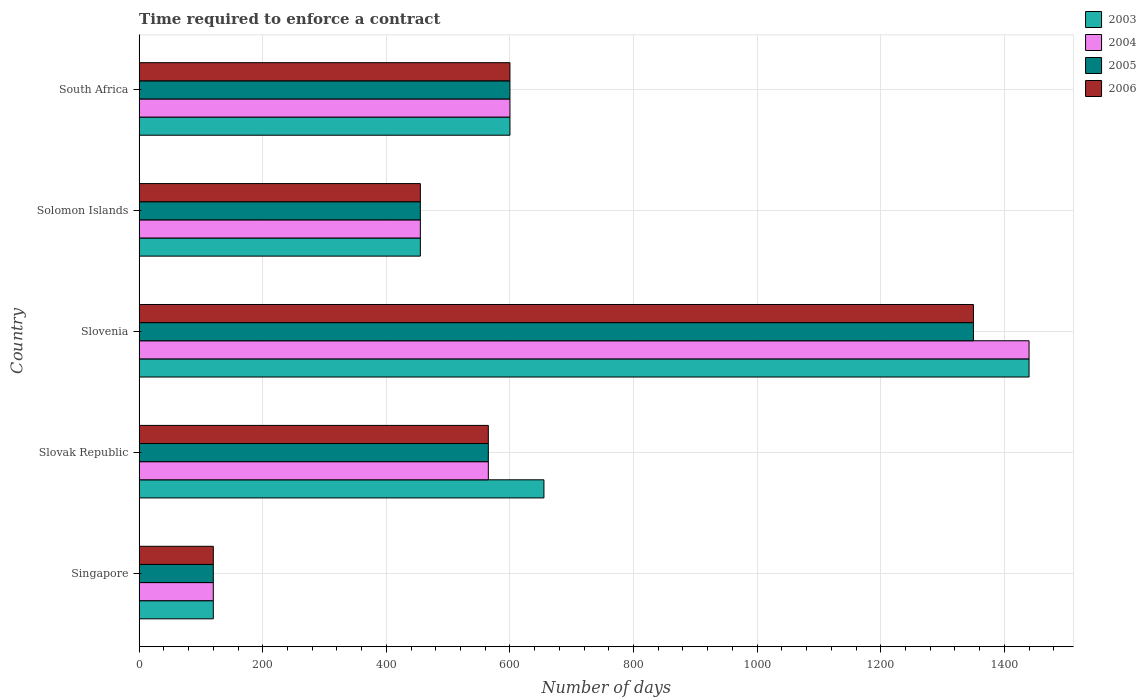Are the number of bars per tick equal to the number of legend labels?
Keep it short and to the point. Yes. Are the number of bars on each tick of the Y-axis equal?
Provide a short and direct response. Yes. How many bars are there on the 1st tick from the top?
Your answer should be very brief. 4. What is the label of the 5th group of bars from the top?
Offer a terse response. Singapore. In how many cases, is the number of bars for a given country not equal to the number of legend labels?
Offer a terse response. 0. What is the number of days required to enforce a contract in 2005 in Slovak Republic?
Offer a terse response. 565. Across all countries, what is the maximum number of days required to enforce a contract in 2004?
Your answer should be compact. 1440. Across all countries, what is the minimum number of days required to enforce a contract in 2005?
Make the answer very short. 120. In which country was the number of days required to enforce a contract in 2003 maximum?
Offer a terse response. Slovenia. In which country was the number of days required to enforce a contract in 2004 minimum?
Offer a terse response. Singapore. What is the total number of days required to enforce a contract in 2003 in the graph?
Ensure brevity in your answer.  3270. What is the difference between the number of days required to enforce a contract in 2006 in Singapore and that in Slovak Republic?
Keep it short and to the point. -445. What is the difference between the number of days required to enforce a contract in 2005 in Slovenia and the number of days required to enforce a contract in 2006 in Solomon Islands?
Keep it short and to the point. 895. What is the average number of days required to enforce a contract in 2004 per country?
Offer a terse response. 636. What is the difference between the number of days required to enforce a contract in 2004 and number of days required to enforce a contract in 2005 in Solomon Islands?
Offer a very short reply. 0. In how many countries, is the number of days required to enforce a contract in 2006 greater than 160 days?
Keep it short and to the point. 4. What is the ratio of the number of days required to enforce a contract in 2003 in Slovak Republic to that in Solomon Islands?
Ensure brevity in your answer.  1.44. What is the difference between the highest and the second highest number of days required to enforce a contract in 2005?
Make the answer very short. 750. What is the difference between the highest and the lowest number of days required to enforce a contract in 2004?
Give a very brief answer. 1320. Is the sum of the number of days required to enforce a contract in 2006 in Singapore and Slovak Republic greater than the maximum number of days required to enforce a contract in 2005 across all countries?
Your response must be concise. No. Is it the case that in every country, the sum of the number of days required to enforce a contract in 2005 and number of days required to enforce a contract in 2006 is greater than the sum of number of days required to enforce a contract in 2004 and number of days required to enforce a contract in 2003?
Your answer should be compact. No. What does the 1st bar from the top in Slovak Republic represents?
Offer a terse response. 2006. What does the 2nd bar from the bottom in South Africa represents?
Your answer should be compact. 2004. Is it the case that in every country, the sum of the number of days required to enforce a contract in 2004 and number of days required to enforce a contract in 2005 is greater than the number of days required to enforce a contract in 2006?
Give a very brief answer. Yes. How many bars are there?
Make the answer very short. 20. Are all the bars in the graph horizontal?
Your answer should be very brief. Yes. Are the values on the major ticks of X-axis written in scientific E-notation?
Offer a very short reply. No. Does the graph contain any zero values?
Offer a very short reply. No. Does the graph contain grids?
Provide a short and direct response. Yes. What is the title of the graph?
Your answer should be compact. Time required to enforce a contract. What is the label or title of the X-axis?
Give a very brief answer. Number of days. What is the label or title of the Y-axis?
Provide a succinct answer. Country. What is the Number of days in 2003 in Singapore?
Ensure brevity in your answer.  120. What is the Number of days in 2004 in Singapore?
Provide a succinct answer. 120. What is the Number of days in 2005 in Singapore?
Offer a very short reply. 120. What is the Number of days in 2006 in Singapore?
Keep it short and to the point. 120. What is the Number of days in 2003 in Slovak Republic?
Ensure brevity in your answer.  655. What is the Number of days of 2004 in Slovak Republic?
Your answer should be compact. 565. What is the Number of days in 2005 in Slovak Republic?
Give a very brief answer. 565. What is the Number of days of 2006 in Slovak Republic?
Provide a succinct answer. 565. What is the Number of days of 2003 in Slovenia?
Make the answer very short. 1440. What is the Number of days of 2004 in Slovenia?
Keep it short and to the point. 1440. What is the Number of days of 2005 in Slovenia?
Your answer should be very brief. 1350. What is the Number of days of 2006 in Slovenia?
Provide a succinct answer. 1350. What is the Number of days of 2003 in Solomon Islands?
Your answer should be very brief. 455. What is the Number of days in 2004 in Solomon Islands?
Provide a succinct answer. 455. What is the Number of days of 2005 in Solomon Islands?
Make the answer very short. 455. What is the Number of days in 2006 in Solomon Islands?
Provide a succinct answer. 455. What is the Number of days in 2003 in South Africa?
Offer a very short reply. 600. What is the Number of days of 2004 in South Africa?
Give a very brief answer. 600. What is the Number of days in 2005 in South Africa?
Offer a very short reply. 600. What is the Number of days in 2006 in South Africa?
Keep it short and to the point. 600. Across all countries, what is the maximum Number of days in 2003?
Make the answer very short. 1440. Across all countries, what is the maximum Number of days in 2004?
Give a very brief answer. 1440. Across all countries, what is the maximum Number of days in 2005?
Provide a succinct answer. 1350. Across all countries, what is the maximum Number of days in 2006?
Give a very brief answer. 1350. Across all countries, what is the minimum Number of days of 2003?
Offer a very short reply. 120. Across all countries, what is the minimum Number of days in 2004?
Offer a terse response. 120. Across all countries, what is the minimum Number of days of 2005?
Offer a very short reply. 120. Across all countries, what is the minimum Number of days in 2006?
Offer a terse response. 120. What is the total Number of days in 2003 in the graph?
Provide a short and direct response. 3270. What is the total Number of days in 2004 in the graph?
Offer a terse response. 3180. What is the total Number of days of 2005 in the graph?
Offer a terse response. 3090. What is the total Number of days in 2006 in the graph?
Offer a terse response. 3090. What is the difference between the Number of days of 2003 in Singapore and that in Slovak Republic?
Provide a short and direct response. -535. What is the difference between the Number of days in 2004 in Singapore and that in Slovak Republic?
Make the answer very short. -445. What is the difference between the Number of days of 2005 in Singapore and that in Slovak Republic?
Make the answer very short. -445. What is the difference between the Number of days of 2006 in Singapore and that in Slovak Republic?
Provide a short and direct response. -445. What is the difference between the Number of days in 2003 in Singapore and that in Slovenia?
Offer a very short reply. -1320. What is the difference between the Number of days in 2004 in Singapore and that in Slovenia?
Your answer should be compact. -1320. What is the difference between the Number of days in 2005 in Singapore and that in Slovenia?
Keep it short and to the point. -1230. What is the difference between the Number of days in 2006 in Singapore and that in Slovenia?
Make the answer very short. -1230. What is the difference between the Number of days of 2003 in Singapore and that in Solomon Islands?
Ensure brevity in your answer.  -335. What is the difference between the Number of days of 2004 in Singapore and that in Solomon Islands?
Offer a terse response. -335. What is the difference between the Number of days in 2005 in Singapore and that in Solomon Islands?
Make the answer very short. -335. What is the difference between the Number of days in 2006 in Singapore and that in Solomon Islands?
Offer a terse response. -335. What is the difference between the Number of days of 2003 in Singapore and that in South Africa?
Provide a succinct answer. -480. What is the difference between the Number of days of 2004 in Singapore and that in South Africa?
Provide a short and direct response. -480. What is the difference between the Number of days in 2005 in Singapore and that in South Africa?
Offer a very short reply. -480. What is the difference between the Number of days in 2006 in Singapore and that in South Africa?
Your answer should be compact. -480. What is the difference between the Number of days of 2003 in Slovak Republic and that in Slovenia?
Provide a short and direct response. -785. What is the difference between the Number of days of 2004 in Slovak Republic and that in Slovenia?
Provide a short and direct response. -875. What is the difference between the Number of days in 2005 in Slovak Republic and that in Slovenia?
Ensure brevity in your answer.  -785. What is the difference between the Number of days in 2006 in Slovak Republic and that in Slovenia?
Your response must be concise. -785. What is the difference between the Number of days of 2004 in Slovak Republic and that in Solomon Islands?
Make the answer very short. 110. What is the difference between the Number of days in 2005 in Slovak Republic and that in Solomon Islands?
Offer a terse response. 110. What is the difference between the Number of days of 2006 in Slovak Republic and that in Solomon Islands?
Provide a short and direct response. 110. What is the difference between the Number of days of 2004 in Slovak Republic and that in South Africa?
Provide a short and direct response. -35. What is the difference between the Number of days in 2005 in Slovak Republic and that in South Africa?
Offer a terse response. -35. What is the difference between the Number of days in 2006 in Slovak Republic and that in South Africa?
Your answer should be very brief. -35. What is the difference between the Number of days of 2003 in Slovenia and that in Solomon Islands?
Offer a terse response. 985. What is the difference between the Number of days in 2004 in Slovenia and that in Solomon Islands?
Make the answer very short. 985. What is the difference between the Number of days of 2005 in Slovenia and that in Solomon Islands?
Make the answer very short. 895. What is the difference between the Number of days in 2006 in Slovenia and that in Solomon Islands?
Make the answer very short. 895. What is the difference between the Number of days of 2003 in Slovenia and that in South Africa?
Your answer should be compact. 840. What is the difference between the Number of days in 2004 in Slovenia and that in South Africa?
Provide a succinct answer. 840. What is the difference between the Number of days of 2005 in Slovenia and that in South Africa?
Your answer should be compact. 750. What is the difference between the Number of days in 2006 in Slovenia and that in South Africa?
Offer a very short reply. 750. What is the difference between the Number of days of 2003 in Solomon Islands and that in South Africa?
Provide a short and direct response. -145. What is the difference between the Number of days of 2004 in Solomon Islands and that in South Africa?
Your answer should be compact. -145. What is the difference between the Number of days of 2005 in Solomon Islands and that in South Africa?
Give a very brief answer. -145. What is the difference between the Number of days of 2006 in Solomon Islands and that in South Africa?
Offer a terse response. -145. What is the difference between the Number of days in 2003 in Singapore and the Number of days in 2004 in Slovak Republic?
Your response must be concise. -445. What is the difference between the Number of days in 2003 in Singapore and the Number of days in 2005 in Slovak Republic?
Make the answer very short. -445. What is the difference between the Number of days of 2003 in Singapore and the Number of days of 2006 in Slovak Republic?
Provide a short and direct response. -445. What is the difference between the Number of days of 2004 in Singapore and the Number of days of 2005 in Slovak Republic?
Make the answer very short. -445. What is the difference between the Number of days in 2004 in Singapore and the Number of days in 2006 in Slovak Republic?
Provide a short and direct response. -445. What is the difference between the Number of days of 2005 in Singapore and the Number of days of 2006 in Slovak Republic?
Your answer should be very brief. -445. What is the difference between the Number of days of 2003 in Singapore and the Number of days of 2004 in Slovenia?
Ensure brevity in your answer.  -1320. What is the difference between the Number of days in 2003 in Singapore and the Number of days in 2005 in Slovenia?
Offer a terse response. -1230. What is the difference between the Number of days in 2003 in Singapore and the Number of days in 2006 in Slovenia?
Your answer should be very brief. -1230. What is the difference between the Number of days of 2004 in Singapore and the Number of days of 2005 in Slovenia?
Provide a short and direct response. -1230. What is the difference between the Number of days in 2004 in Singapore and the Number of days in 2006 in Slovenia?
Ensure brevity in your answer.  -1230. What is the difference between the Number of days in 2005 in Singapore and the Number of days in 2006 in Slovenia?
Offer a very short reply. -1230. What is the difference between the Number of days in 2003 in Singapore and the Number of days in 2004 in Solomon Islands?
Give a very brief answer. -335. What is the difference between the Number of days in 2003 in Singapore and the Number of days in 2005 in Solomon Islands?
Your response must be concise. -335. What is the difference between the Number of days in 2003 in Singapore and the Number of days in 2006 in Solomon Islands?
Offer a very short reply. -335. What is the difference between the Number of days in 2004 in Singapore and the Number of days in 2005 in Solomon Islands?
Offer a very short reply. -335. What is the difference between the Number of days in 2004 in Singapore and the Number of days in 2006 in Solomon Islands?
Offer a very short reply. -335. What is the difference between the Number of days in 2005 in Singapore and the Number of days in 2006 in Solomon Islands?
Keep it short and to the point. -335. What is the difference between the Number of days in 2003 in Singapore and the Number of days in 2004 in South Africa?
Provide a succinct answer. -480. What is the difference between the Number of days of 2003 in Singapore and the Number of days of 2005 in South Africa?
Your answer should be compact. -480. What is the difference between the Number of days in 2003 in Singapore and the Number of days in 2006 in South Africa?
Provide a short and direct response. -480. What is the difference between the Number of days of 2004 in Singapore and the Number of days of 2005 in South Africa?
Your answer should be compact. -480. What is the difference between the Number of days of 2004 in Singapore and the Number of days of 2006 in South Africa?
Provide a succinct answer. -480. What is the difference between the Number of days in 2005 in Singapore and the Number of days in 2006 in South Africa?
Keep it short and to the point. -480. What is the difference between the Number of days in 2003 in Slovak Republic and the Number of days in 2004 in Slovenia?
Offer a very short reply. -785. What is the difference between the Number of days of 2003 in Slovak Republic and the Number of days of 2005 in Slovenia?
Provide a short and direct response. -695. What is the difference between the Number of days in 2003 in Slovak Republic and the Number of days in 2006 in Slovenia?
Ensure brevity in your answer.  -695. What is the difference between the Number of days in 2004 in Slovak Republic and the Number of days in 2005 in Slovenia?
Provide a short and direct response. -785. What is the difference between the Number of days in 2004 in Slovak Republic and the Number of days in 2006 in Slovenia?
Ensure brevity in your answer.  -785. What is the difference between the Number of days of 2005 in Slovak Republic and the Number of days of 2006 in Slovenia?
Provide a short and direct response. -785. What is the difference between the Number of days in 2003 in Slovak Republic and the Number of days in 2004 in Solomon Islands?
Give a very brief answer. 200. What is the difference between the Number of days in 2003 in Slovak Republic and the Number of days in 2005 in Solomon Islands?
Your answer should be very brief. 200. What is the difference between the Number of days in 2003 in Slovak Republic and the Number of days in 2006 in Solomon Islands?
Your response must be concise. 200. What is the difference between the Number of days of 2004 in Slovak Republic and the Number of days of 2005 in Solomon Islands?
Your answer should be very brief. 110. What is the difference between the Number of days of 2004 in Slovak Republic and the Number of days of 2006 in Solomon Islands?
Offer a terse response. 110. What is the difference between the Number of days in 2005 in Slovak Republic and the Number of days in 2006 in Solomon Islands?
Your response must be concise. 110. What is the difference between the Number of days in 2003 in Slovak Republic and the Number of days in 2004 in South Africa?
Offer a terse response. 55. What is the difference between the Number of days of 2004 in Slovak Republic and the Number of days of 2005 in South Africa?
Offer a very short reply. -35. What is the difference between the Number of days of 2004 in Slovak Republic and the Number of days of 2006 in South Africa?
Your response must be concise. -35. What is the difference between the Number of days in 2005 in Slovak Republic and the Number of days in 2006 in South Africa?
Give a very brief answer. -35. What is the difference between the Number of days in 2003 in Slovenia and the Number of days in 2004 in Solomon Islands?
Offer a very short reply. 985. What is the difference between the Number of days of 2003 in Slovenia and the Number of days of 2005 in Solomon Islands?
Keep it short and to the point. 985. What is the difference between the Number of days in 2003 in Slovenia and the Number of days in 2006 in Solomon Islands?
Make the answer very short. 985. What is the difference between the Number of days of 2004 in Slovenia and the Number of days of 2005 in Solomon Islands?
Offer a terse response. 985. What is the difference between the Number of days in 2004 in Slovenia and the Number of days in 2006 in Solomon Islands?
Your answer should be very brief. 985. What is the difference between the Number of days in 2005 in Slovenia and the Number of days in 2006 in Solomon Islands?
Make the answer very short. 895. What is the difference between the Number of days in 2003 in Slovenia and the Number of days in 2004 in South Africa?
Your answer should be very brief. 840. What is the difference between the Number of days in 2003 in Slovenia and the Number of days in 2005 in South Africa?
Ensure brevity in your answer.  840. What is the difference between the Number of days in 2003 in Slovenia and the Number of days in 2006 in South Africa?
Your response must be concise. 840. What is the difference between the Number of days in 2004 in Slovenia and the Number of days in 2005 in South Africa?
Keep it short and to the point. 840. What is the difference between the Number of days in 2004 in Slovenia and the Number of days in 2006 in South Africa?
Your answer should be very brief. 840. What is the difference between the Number of days of 2005 in Slovenia and the Number of days of 2006 in South Africa?
Provide a short and direct response. 750. What is the difference between the Number of days of 2003 in Solomon Islands and the Number of days of 2004 in South Africa?
Give a very brief answer. -145. What is the difference between the Number of days of 2003 in Solomon Islands and the Number of days of 2005 in South Africa?
Your response must be concise. -145. What is the difference between the Number of days of 2003 in Solomon Islands and the Number of days of 2006 in South Africa?
Make the answer very short. -145. What is the difference between the Number of days in 2004 in Solomon Islands and the Number of days in 2005 in South Africa?
Keep it short and to the point. -145. What is the difference between the Number of days of 2004 in Solomon Islands and the Number of days of 2006 in South Africa?
Your answer should be very brief. -145. What is the difference between the Number of days in 2005 in Solomon Islands and the Number of days in 2006 in South Africa?
Ensure brevity in your answer.  -145. What is the average Number of days in 2003 per country?
Your answer should be very brief. 654. What is the average Number of days in 2004 per country?
Provide a succinct answer. 636. What is the average Number of days of 2005 per country?
Make the answer very short. 618. What is the average Number of days in 2006 per country?
Keep it short and to the point. 618. What is the difference between the Number of days of 2003 and Number of days of 2004 in Singapore?
Offer a terse response. 0. What is the difference between the Number of days in 2004 and Number of days in 2005 in Singapore?
Your answer should be very brief. 0. What is the difference between the Number of days in 2004 and Number of days in 2006 in Singapore?
Offer a very short reply. 0. What is the difference between the Number of days in 2005 and Number of days in 2006 in Singapore?
Offer a terse response. 0. What is the difference between the Number of days in 2003 and Number of days in 2004 in Slovak Republic?
Provide a succinct answer. 90. What is the difference between the Number of days in 2003 and Number of days in 2006 in Slovak Republic?
Ensure brevity in your answer.  90. What is the difference between the Number of days in 2004 and Number of days in 2005 in Slovak Republic?
Your answer should be compact. 0. What is the difference between the Number of days in 2003 and Number of days in 2005 in Slovenia?
Provide a succinct answer. 90. What is the difference between the Number of days of 2004 and Number of days of 2005 in Slovenia?
Provide a succinct answer. 90. What is the difference between the Number of days of 2003 and Number of days of 2004 in Solomon Islands?
Ensure brevity in your answer.  0. What is the difference between the Number of days in 2003 and Number of days in 2006 in Solomon Islands?
Offer a very short reply. 0. What is the difference between the Number of days in 2004 and Number of days in 2005 in South Africa?
Your answer should be compact. 0. What is the difference between the Number of days in 2004 and Number of days in 2006 in South Africa?
Your answer should be compact. 0. What is the ratio of the Number of days of 2003 in Singapore to that in Slovak Republic?
Give a very brief answer. 0.18. What is the ratio of the Number of days in 2004 in Singapore to that in Slovak Republic?
Ensure brevity in your answer.  0.21. What is the ratio of the Number of days in 2005 in Singapore to that in Slovak Republic?
Your response must be concise. 0.21. What is the ratio of the Number of days of 2006 in Singapore to that in Slovak Republic?
Ensure brevity in your answer.  0.21. What is the ratio of the Number of days in 2003 in Singapore to that in Slovenia?
Make the answer very short. 0.08. What is the ratio of the Number of days of 2004 in Singapore to that in Slovenia?
Give a very brief answer. 0.08. What is the ratio of the Number of days in 2005 in Singapore to that in Slovenia?
Your answer should be compact. 0.09. What is the ratio of the Number of days in 2006 in Singapore to that in Slovenia?
Ensure brevity in your answer.  0.09. What is the ratio of the Number of days of 2003 in Singapore to that in Solomon Islands?
Ensure brevity in your answer.  0.26. What is the ratio of the Number of days of 2004 in Singapore to that in Solomon Islands?
Your answer should be compact. 0.26. What is the ratio of the Number of days in 2005 in Singapore to that in Solomon Islands?
Your response must be concise. 0.26. What is the ratio of the Number of days of 2006 in Singapore to that in Solomon Islands?
Give a very brief answer. 0.26. What is the ratio of the Number of days of 2005 in Singapore to that in South Africa?
Offer a very short reply. 0.2. What is the ratio of the Number of days of 2006 in Singapore to that in South Africa?
Your answer should be very brief. 0.2. What is the ratio of the Number of days of 2003 in Slovak Republic to that in Slovenia?
Offer a terse response. 0.45. What is the ratio of the Number of days in 2004 in Slovak Republic to that in Slovenia?
Keep it short and to the point. 0.39. What is the ratio of the Number of days of 2005 in Slovak Republic to that in Slovenia?
Offer a terse response. 0.42. What is the ratio of the Number of days of 2006 in Slovak Republic to that in Slovenia?
Keep it short and to the point. 0.42. What is the ratio of the Number of days of 2003 in Slovak Republic to that in Solomon Islands?
Offer a very short reply. 1.44. What is the ratio of the Number of days of 2004 in Slovak Republic to that in Solomon Islands?
Offer a very short reply. 1.24. What is the ratio of the Number of days in 2005 in Slovak Republic to that in Solomon Islands?
Make the answer very short. 1.24. What is the ratio of the Number of days in 2006 in Slovak Republic to that in Solomon Islands?
Offer a very short reply. 1.24. What is the ratio of the Number of days of 2003 in Slovak Republic to that in South Africa?
Offer a very short reply. 1.09. What is the ratio of the Number of days of 2004 in Slovak Republic to that in South Africa?
Your answer should be compact. 0.94. What is the ratio of the Number of days in 2005 in Slovak Republic to that in South Africa?
Your answer should be very brief. 0.94. What is the ratio of the Number of days in 2006 in Slovak Republic to that in South Africa?
Your answer should be very brief. 0.94. What is the ratio of the Number of days in 2003 in Slovenia to that in Solomon Islands?
Provide a short and direct response. 3.16. What is the ratio of the Number of days in 2004 in Slovenia to that in Solomon Islands?
Your answer should be compact. 3.16. What is the ratio of the Number of days of 2005 in Slovenia to that in Solomon Islands?
Offer a very short reply. 2.97. What is the ratio of the Number of days in 2006 in Slovenia to that in Solomon Islands?
Your response must be concise. 2.97. What is the ratio of the Number of days of 2003 in Slovenia to that in South Africa?
Your response must be concise. 2.4. What is the ratio of the Number of days of 2005 in Slovenia to that in South Africa?
Your response must be concise. 2.25. What is the ratio of the Number of days in 2006 in Slovenia to that in South Africa?
Your answer should be compact. 2.25. What is the ratio of the Number of days in 2003 in Solomon Islands to that in South Africa?
Provide a short and direct response. 0.76. What is the ratio of the Number of days of 2004 in Solomon Islands to that in South Africa?
Offer a terse response. 0.76. What is the ratio of the Number of days in 2005 in Solomon Islands to that in South Africa?
Ensure brevity in your answer.  0.76. What is the ratio of the Number of days in 2006 in Solomon Islands to that in South Africa?
Offer a very short reply. 0.76. What is the difference between the highest and the second highest Number of days of 2003?
Provide a short and direct response. 785. What is the difference between the highest and the second highest Number of days in 2004?
Give a very brief answer. 840. What is the difference between the highest and the second highest Number of days of 2005?
Your answer should be compact. 750. What is the difference between the highest and the second highest Number of days of 2006?
Ensure brevity in your answer.  750. What is the difference between the highest and the lowest Number of days in 2003?
Make the answer very short. 1320. What is the difference between the highest and the lowest Number of days of 2004?
Make the answer very short. 1320. What is the difference between the highest and the lowest Number of days of 2005?
Your response must be concise. 1230. What is the difference between the highest and the lowest Number of days of 2006?
Your answer should be compact. 1230. 